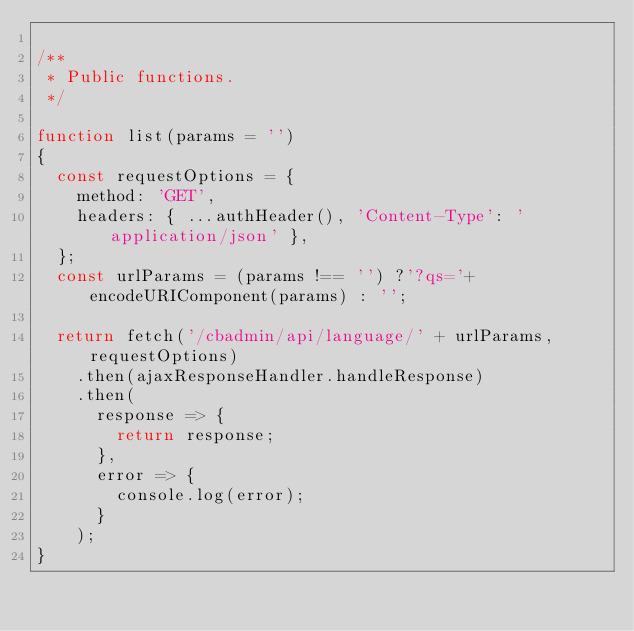Convert code to text. <code><loc_0><loc_0><loc_500><loc_500><_JavaScript_>
/**
 * Public functions.
 */

function list(params = '')
{
  const requestOptions = {
    method: 'GET',
    headers: { ...authHeader(), 'Content-Type': 'application/json' },
  };
  const urlParams = (params !== '') ?'?qs='+ encodeURIComponent(params) : '';

  return fetch('/cbadmin/api/language/' + urlParams, requestOptions)
    .then(ajaxResponseHandler.handleResponse)
    .then(
      response => {
        return response;
      },
      error => {
        console.log(error);
      }
    );
}</code> 